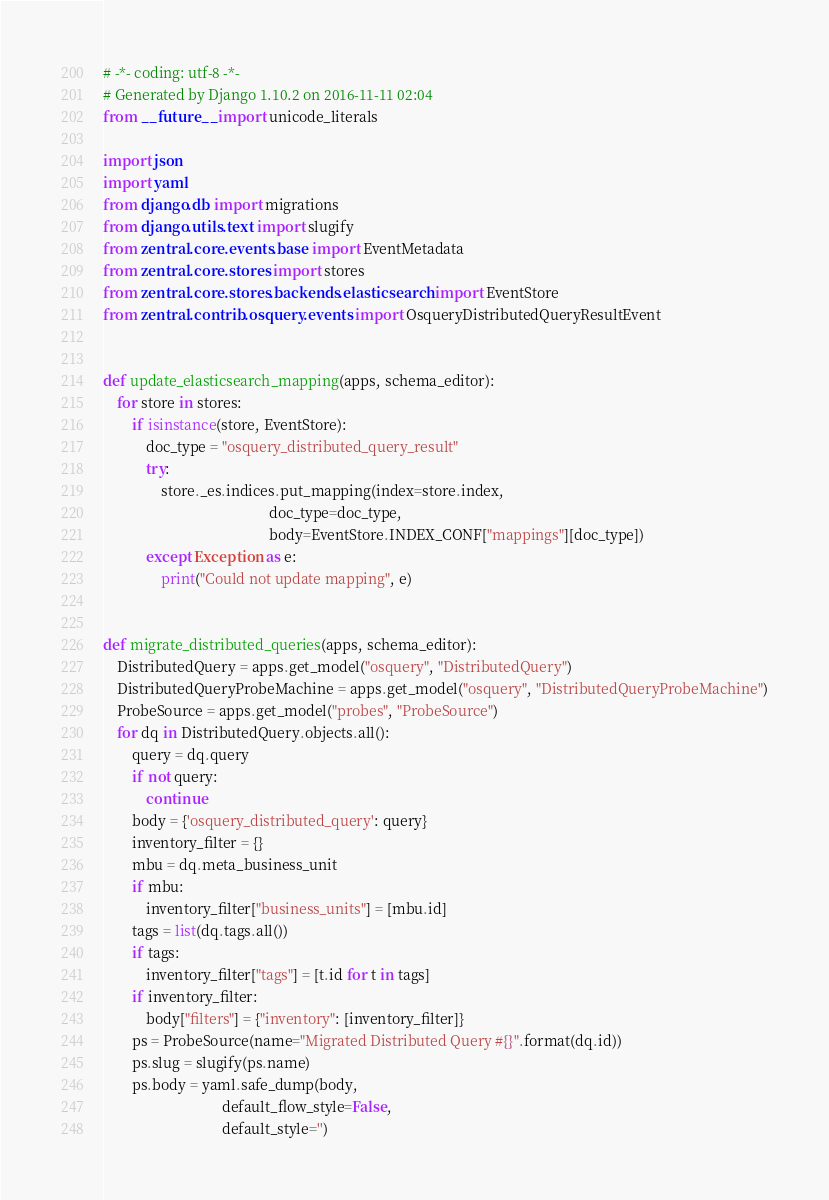Convert code to text. <code><loc_0><loc_0><loc_500><loc_500><_Python_># -*- coding: utf-8 -*-
# Generated by Django 1.10.2 on 2016-11-11 02:04
from __future__ import unicode_literals

import json
import yaml
from django.db import migrations
from django.utils.text import slugify
from zentral.core.events.base import EventMetadata
from zentral.core.stores import stores
from zentral.core.stores.backends.elasticsearch import EventStore
from zentral.contrib.osquery.events import OsqueryDistributedQueryResultEvent


def update_elasticsearch_mapping(apps, schema_editor):
    for store in stores:
        if isinstance(store, EventStore):
            doc_type = "osquery_distributed_query_result"
            try:
                store._es.indices.put_mapping(index=store.index,
                                              doc_type=doc_type,
                                              body=EventStore.INDEX_CONF["mappings"][doc_type])
            except Exception as e:
                print("Could not update mapping", e)


def migrate_distributed_queries(apps, schema_editor):
    DistributedQuery = apps.get_model("osquery", "DistributedQuery")
    DistributedQueryProbeMachine = apps.get_model("osquery", "DistributedQueryProbeMachine")
    ProbeSource = apps.get_model("probes", "ProbeSource")
    for dq in DistributedQuery.objects.all():
        query = dq.query
        if not query:
            continue
        body = {'osquery_distributed_query': query}
        inventory_filter = {}
        mbu = dq.meta_business_unit
        if mbu:
            inventory_filter["business_units"] = [mbu.id]
        tags = list(dq.tags.all())
        if tags:
            inventory_filter["tags"] = [t.id for t in tags]
        if inventory_filter:
            body["filters"] = {"inventory": [inventory_filter]}
        ps = ProbeSource(name="Migrated Distributed Query #{}".format(dq.id))
        ps.slug = slugify(ps.name)
        ps.body = yaml.safe_dump(body,
                                 default_flow_style=False,
                                 default_style='')</code> 